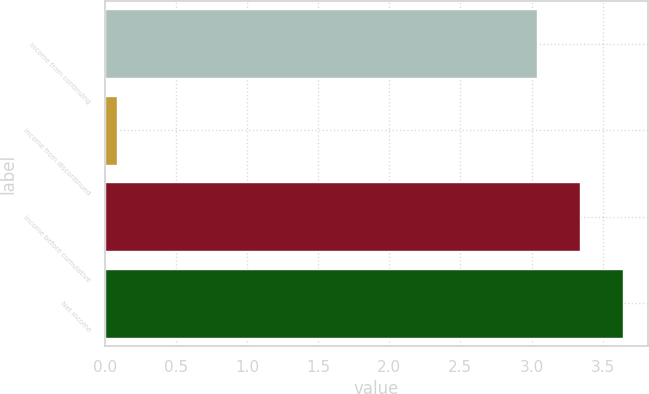Convert chart. <chart><loc_0><loc_0><loc_500><loc_500><bar_chart><fcel>Income from continuing<fcel>Income from discontinued<fcel>Income before cumulative<fcel>Net income<nl><fcel>3.04<fcel>0.09<fcel>3.34<fcel>3.64<nl></chart> 